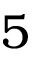Convert formula to latex. <formula><loc_0><loc_0><loc_500><loc_500>5</formula> 